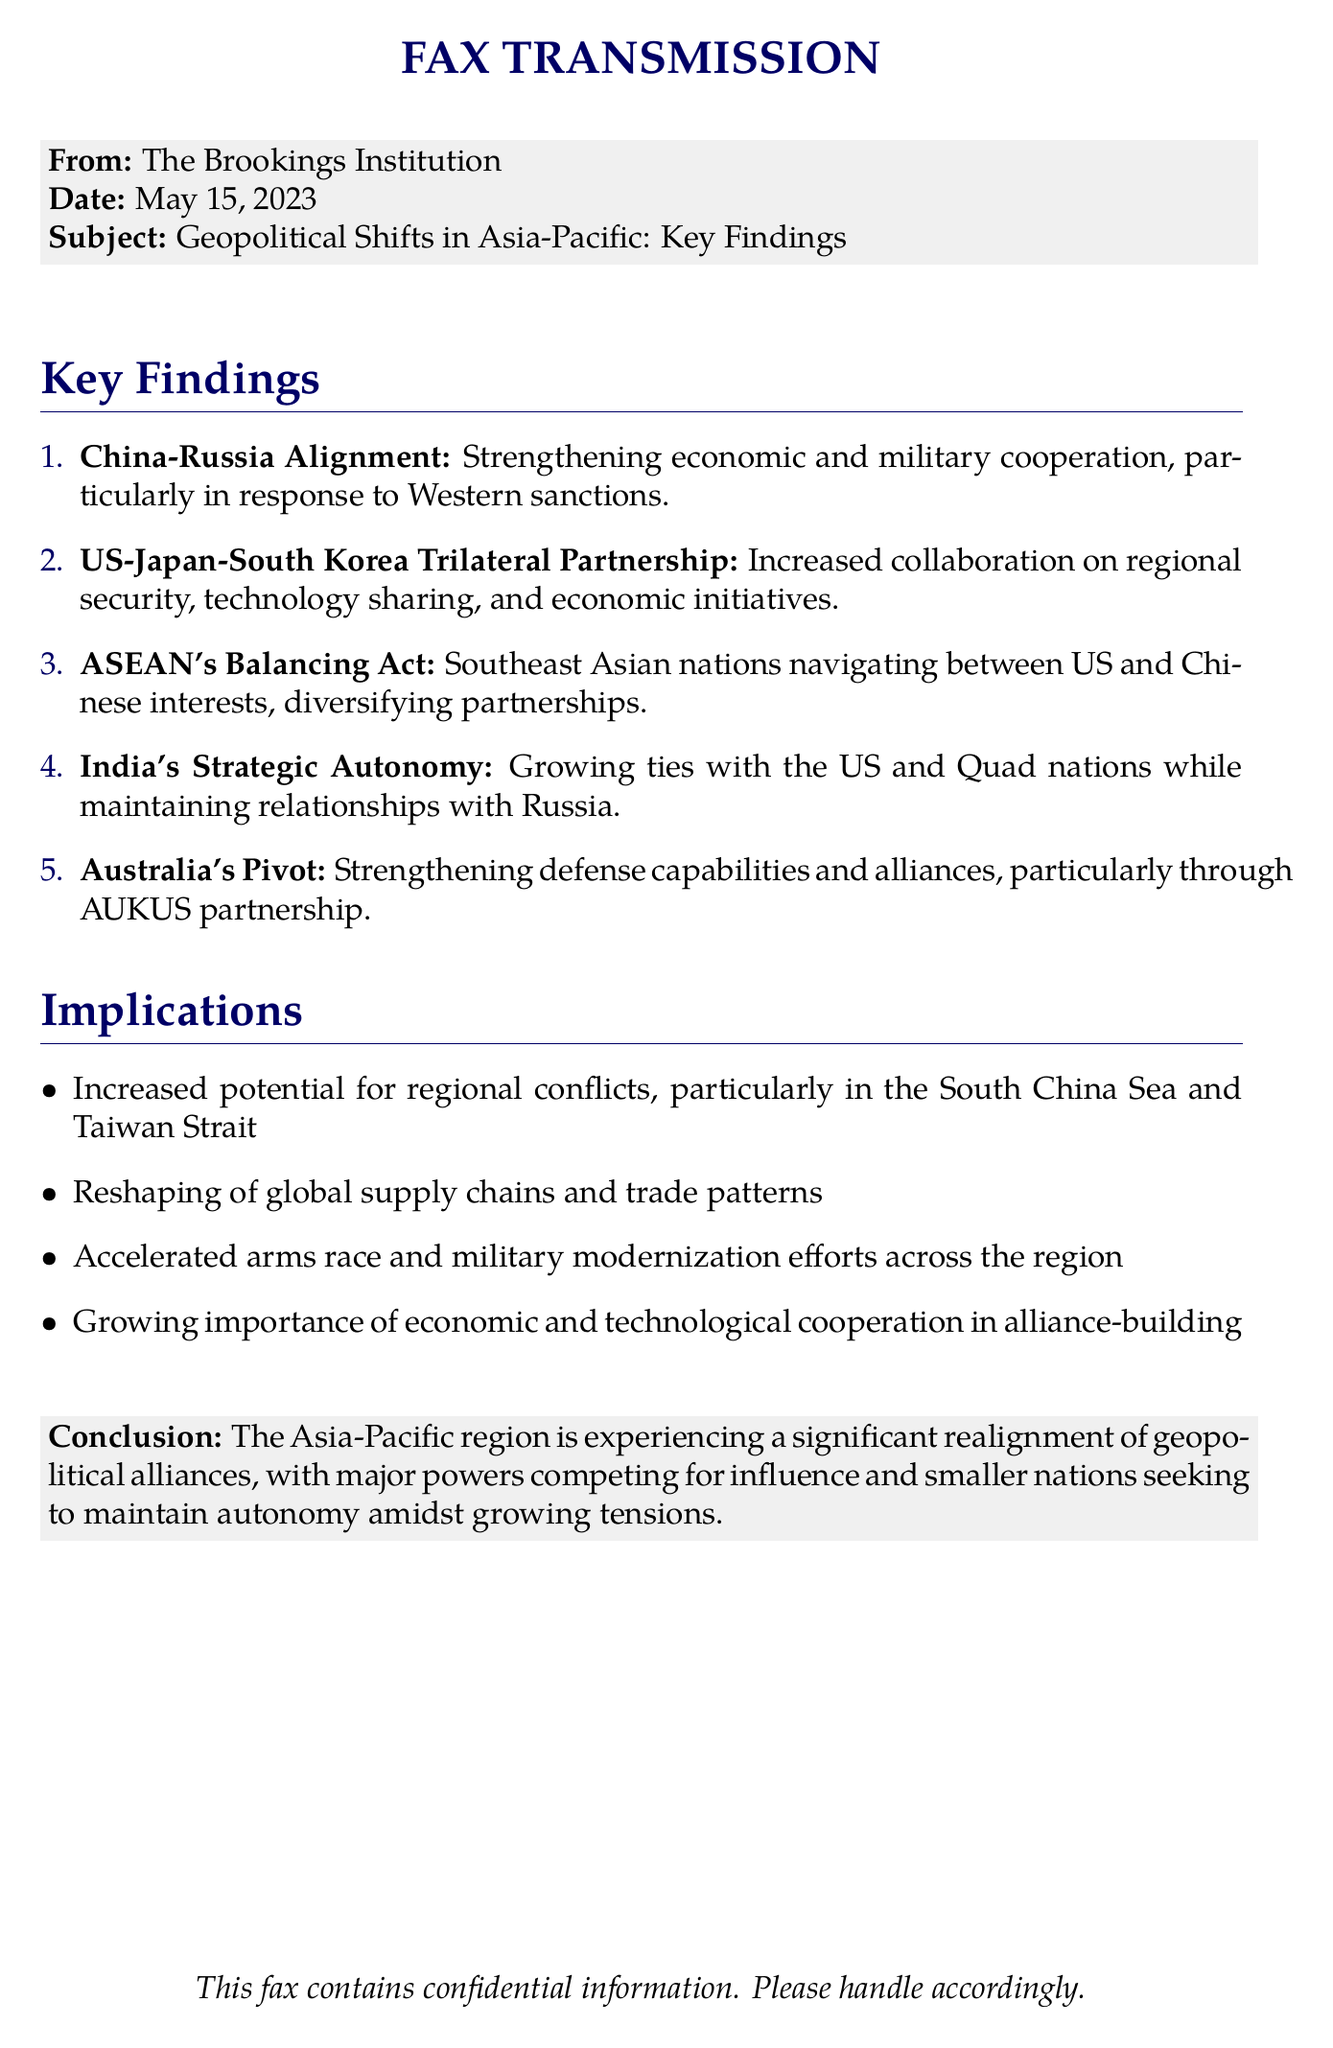what is the date of the document? The date of the document is specified in the header section, which states May 15, 2023.
Answer: May 15, 2023 who authored the document? The document states that it is from The Brookings Institution, which is the author.
Answer: The Brookings Institution what is the first key finding? The first key finding discusses the strengthening economic and military cooperation between China and Russia.
Answer: China-Russia Alignment how many key findings are there? The number of key findings is listed as five in the enumeration.
Answer: 5 what is the conclusion of the document? The conclusion section summarizes the experience of significant realignment of geopolitical alliances in the Asia-Pacific region.
Answer: Geopolitical alliances realignment which partnership is Australia strengthening? The document mentions a specific partnership that Australia is focused on, which is AUKUS.
Answer: AUKUS what does ASEAN's balancing act involve? ASEAN's balancing act is described as navigating between US and Chinese interests while diversifying partnerships.
Answer: US and Chinese interests what are the implications mentioned? The implications listed include increased potential for regional conflicts, reshaping of global supply chains, and accelerated arms race.
Answer: Increased potential for regional conflicts what type of document is this? The format of the document indicates that it is a fax transmission.
Answer: fax transmission 